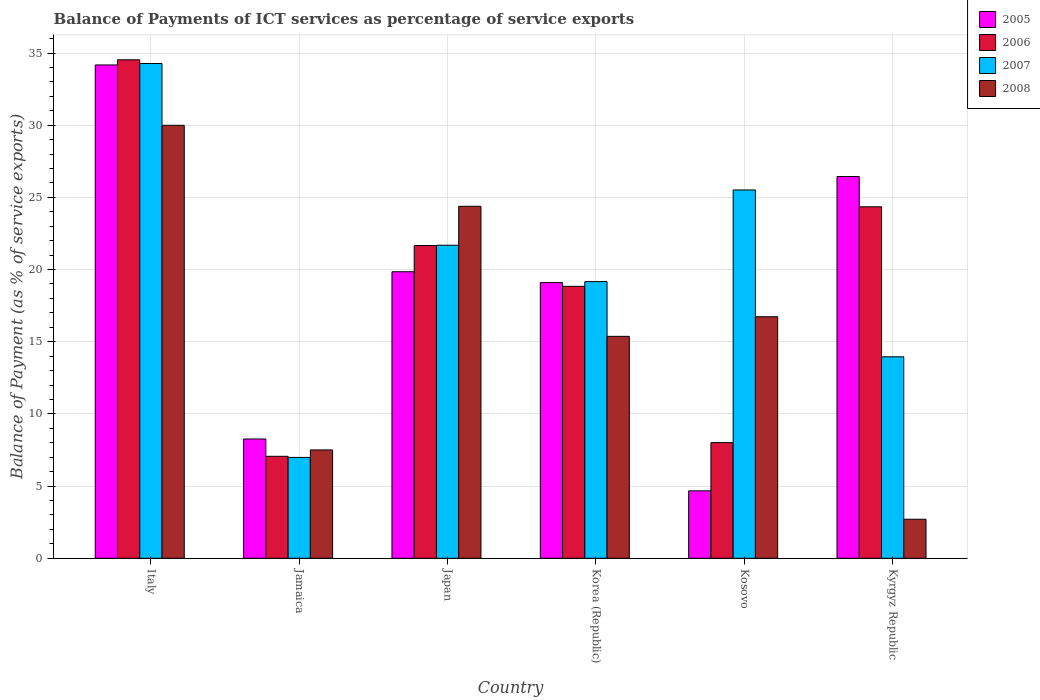How many different coloured bars are there?
Provide a succinct answer. 4. Are the number of bars on each tick of the X-axis equal?
Provide a short and direct response. Yes. How many bars are there on the 5th tick from the right?
Your answer should be very brief. 4. What is the label of the 5th group of bars from the left?
Make the answer very short. Kosovo. In how many cases, is the number of bars for a given country not equal to the number of legend labels?
Keep it short and to the point. 0. What is the balance of payments of ICT services in 2006 in Italy?
Offer a very short reply. 34.53. Across all countries, what is the maximum balance of payments of ICT services in 2008?
Offer a very short reply. 29.99. Across all countries, what is the minimum balance of payments of ICT services in 2007?
Keep it short and to the point. 6.99. In which country was the balance of payments of ICT services in 2005 maximum?
Your answer should be compact. Italy. In which country was the balance of payments of ICT services in 2006 minimum?
Your answer should be very brief. Jamaica. What is the total balance of payments of ICT services in 2008 in the graph?
Ensure brevity in your answer.  96.69. What is the difference between the balance of payments of ICT services in 2007 in Japan and that in Kyrgyz Republic?
Your answer should be very brief. 7.73. What is the difference between the balance of payments of ICT services in 2005 in Korea (Republic) and the balance of payments of ICT services in 2006 in Italy?
Your answer should be compact. -15.43. What is the average balance of payments of ICT services in 2007 per country?
Your answer should be compact. 20.26. What is the difference between the balance of payments of ICT services of/in 2006 and balance of payments of ICT services of/in 2005 in Kyrgyz Republic?
Provide a short and direct response. -2.1. In how many countries, is the balance of payments of ICT services in 2008 greater than 8 %?
Give a very brief answer. 4. What is the ratio of the balance of payments of ICT services in 2008 in Jamaica to that in Korea (Republic)?
Offer a very short reply. 0.49. Is the difference between the balance of payments of ICT services in 2006 in Japan and Kosovo greater than the difference between the balance of payments of ICT services in 2005 in Japan and Kosovo?
Keep it short and to the point. No. What is the difference between the highest and the second highest balance of payments of ICT services in 2008?
Your response must be concise. 7.65. What is the difference between the highest and the lowest balance of payments of ICT services in 2008?
Keep it short and to the point. 27.29. In how many countries, is the balance of payments of ICT services in 2005 greater than the average balance of payments of ICT services in 2005 taken over all countries?
Make the answer very short. 4. Is the sum of the balance of payments of ICT services in 2008 in Korea (Republic) and Kosovo greater than the maximum balance of payments of ICT services in 2005 across all countries?
Offer a very short reply. No. Is it the case that in every country, the sum of the balance of payments of ICT services in 2007 and balance of payments of ICT services in 2005 is greater than the sum of balance of payments of ICT services in 2008 and balance of payments of ICT services in 2006?
Make the answer very short. No. What does the 1st bar from the left in Korea (Republic) represents?
Your answer should be very brief. 2005. What does the 4th bar from the right in Kosovo represents?
Give a very brief answer. 2005. Are all the bars in the graph horizontal?
Your response must be concise. No. How many countries are there in the graph?
Keep it short and to the point. 6. What is the difference between two consecutive major ticks on the Y-axis?
Your answer should be very brief. 5. Are the values on the major ticks of Y-axis written in scientific E-notation?
Your answer should be very brief. No. Does the graph contain any zero values?
Your answer should be compact. No. Does the graph contain grids?
Your answer should be compact. Yes. Where does the legend appear in the graph?
Keep it short and to the point. Top right. How many legend labels are there?
Your response must be concise. 4. What is the title of the graph?
Ensure brevity in your answer.  Balance of Payments of ICT services as percentage of service exports. Does "1993" appear as one of the legend labels in the graph?
Your answer should be very brief. No. What is the label or title of the X-axis?
Give a very brief answer. Country. What is the label or title of the Y-axis?
Keep it short and to the point. Balance of Payment (as % of service exports). What is the Balance of Payment (as % of service exports) of 2005 in Italy?
Your answer should be very brief. 34.17. What is the Balance of Payment (as % of service exports) in 2006 in Italy?
Make the answer very short. 34.53. What is the Balance of Payment (as % of service exports) of 2007 in Italy?
Offer a very short reply. 34.28. What is the Balance of Payment (as % of service exports) in 2008 in Italy?
Your answer should be very brief. 29.99. What is the Balance of Payment (as % of service exports) in 2005 in Jamaica?
Your answer should be very brief. 8.26. What is the Balance of Payment (as % of service exports) in 2006 in Jamaica?
Offer a terse response. 7.06. What is the Balance of Payment (as % of service exports) in 2007 in Jamaica?
Make the answer very short. 6.99. What is the Balance of Payment (as % of service exports) of 2008 in Jamaica?
Your answer should be very brief. 7.5. What is the Balance of Payment (as % of service exports) of 2005 in Japan?
Ensure brevity in your answer.  19.85. What is the Balance of Payment (as % of service exports) of 2006 in Japan?
Your response must be concise. 21.67. What is the Balance of Payment (as % of service exports) in 2007 in Japan?
Your response must be concise. 21.69. What is the Balance of Payment (as % of service exports) of 2008 in Japan?
Give a very brief answer. 24.38. What is the Balance of Payment (as % of service exports) in 2005 in Korea (Republic)?
Give a very brief answer. 19.1. What is the Balance of Payment (as % of service exports) of 2006 in Korea (Republic)?
Your response must be concise. 18.84. What is the Balance of Payment (as % of service exports) of 2007 in Korea (Republic)?
Your answer should be compact. 19.16. What is the Balance of Payment (as % of service exports) of 2008 in Korea (Republic)?
Provide a short and direct response. 15.37. What is the Balance of Payment (as % of service exports) of 2005 in Kosovo?
Provide a short and direct response. 4.67. What is the Balance of Payment (as % of service exports) of 2006 in Kosovo?
Your response must be concise. 8.01. What is the Balance of Payment (as % of service exports) of 2007 in Kosovo?
Ensure brevity in your answer.  25.51. What is the Balance of Payment (as % of service exports) of 2008 in Kosovo?
Keep it short and to the point. 16.73. What is the Balance of Payment (as % of service exports) in 2005 in Kyrgyz Republic?
Your answer should be very brief. 26.45. What is the Balance of Payment (as % of service exports) of 2006 in Kyrgyz Republic?
Your answer should be compact. 24.35. What is the Balance of Payment (as % of service exports) of 2007 in Kyrgyz Republic?
Give a very brief answer. 13.96. What is the Balance of Payment (as % of service exports) of 2008 in Kyrgyz Republic?
Provide a short and direct response. 2.7. Across all countries, what is the maximum Balance of Payment (as % of service exports) of 2005?
Your answer should be compact. 34.17. Across all countries, what is the maximum Balance of Payment (as % of service exports) of 2006?
Keep it short and to the point. 34.53. Across all countries, what is the maximum Balance of Payment (as % of service exports) in 2007?
Make the answer very short. 34.28. Across all countries, what is the maximum Balance of Payment (as % of service exports) in 2008?
Your response must be concise. 29.99. Across all countries, what is the minimum Balance of Payment (as % of service exports) in 2005?
Give a very brief answer. 4.67. Across all countries, what is the minimum Balance of Payment (as % of service exports) of 2006?
Provide a succinct answer. 7.06. Across all countries, what is the minimum Balance of Payment (as % of service exports) of 2007?
Your answer should be compact. 6.99. Across all countries, what is the minimum Balance of Payment (as % of service exports) of 2008?
Ensure brevity in your answer.  2.7. What is the total Balance of Payment (as % of service exports) in 2005 in the graph?
Provide a succinct answer. 112.5. What is the total Balance of Payment (as % of service exports) of 2006 in the graph?
Your answer should be compact. 114.46. What is the total Balance of Payment (as % of service exports) of 2007 in the graph?
Your response must be concise. 121.58. What is the total Balance of Payment (as % of service exports) in 2008 in the graph?
Your answer should be compact. 96.69. What is the difference between the Balance of Payment (as % of service exports) of 2005 in Italy and that in Jamaica?
Make the answer very short. 25.91. What is the difference between the Balance of Payment (as % of service exports) of 2006 in Italy and that in Jamaica?
Give a very brief answer. 27.47. What is the difference between the Balance of Payment (as % of service exports) in 2007 in Italy and that in Jamaica?
Make the answer very short. 27.29. What is the difference between the Balance of Payment (as % of service exports) of 2008 in Italy and that in Jamaica?
Ensure brevity in your answer.  22.49. What is the difference between the Balance of Payment (as % of service exports) of 2005 in Italy and that in Japan?
Make the answer very short. 14.33. What is the difference between the Balance of Payment (as % of service exports) in 2006 in Italy and that in Japan?
Offer a very short reply. 12.87. What is the difference between the Balance of Payment (as % of service exports) of 2007 in Italy and that in Japan?
Your answer should be very brief. 12.59. What is the difference between the Balance of Payment (as % of service exports) in 2008 in Italy and that in Japan?
Keep it short and to the point. 5.61. What is the difference between the Balance of Payment (as % of service exports) of 2005 in Italy and that in Korea (Republic)?
Your answer should be compact. 15.08. What is the difference between the Balance of Payment (as % of service exports) in 2006 in Italy and that in Korea (Republic)?
Provide a short and direct response. 15.69. What is the difference between the Balance of Payment (as % of service exports) of 2007 in Italy and that in Korea (Republic)?
Offer a very short reply. 15.11. What is the difference between the Balance of Payment (as % of service exports) of 2008 in Italy and that in Korea (Republic)?
Your answer should be compact. 14.62. What is the difference between the Balance of Payment (as % of service exports) of 2005 in Italy and that in Kosovo?
Your answer should be compact. 29.5. What is the difference between the Balance of Payment (as % of service exports) in 2006 in Italy and that in Kosovo?
Your answer should be compact. 26.52. What is the difference between the Balance of Payment (as % of service exports) in 2007 in Italy and that in Kosovo?
Offer a very short reply. 8.76. What is the difference between the Balance of Payment (as % of service exports) in 2008 in Italy and that in Kosovo?
Your answer should be very brief. 13.26. What is the difference between the Balance of Payment (as % of service exports) of 2005 in Italy and that in Kyrgyz Republic?
Give a very brief answer. 7.73. What is the difference between the Balance of Payment (as % of service exports) in 2006 in Italy and that in Kyrgyz Republic?
Your answer should be compact. 10.18. What is the difference between the Balance of Payment (as % of service exports) of 2007 in Italy and that in Kyrgyz Republic?
Offer a very short reply. 20.32. What is the difference between the Balance of Payment (as % of service exports) in 2008 in Italy and that in Kyrgyz Republic?
Provide a succinct answer. 27.29. What is the difference between the Balance of Payment (as % of service exports) of 2005 in Jamaica and that in Japan?
Provide a succinct answer. -11.59. What is the difference between the Balance of Payment (as % of service exports) of 2006 in Jamaica and that in Japan?
Give a very brief answer. -14.6. What is the difference between the Balance of Payment (as % of service exports) of 2007 in Jamaica and that in Japan?
Make the answer very short. -14.7. What is the difference between the Balance of Payment (as % of service exports) of 2008 in Jamaica and that in Japan?
Offer a terse response. -16.88. What is the difference between the Balance of Payment (as % of service exports) of 2005 in Jamaica and that in Korea (Republic)?
Your answer should be very brief. -10.83. What is the difference between the Balance of Payment (as % of service exports) of 2006 in Jamaica and that in Korea (Republic)?
Provide a short and direct response. -11.78. What is the difference between the Balance of Payment (as % of service exports) of 2007 in Jamaica and that in Korea (Republic)?
Your answer should be very brief. -12.18. What is the difference between the Balance of Payment (as % of service exports) in 2008 in Jamaica and that in Korea (Republic)?
Provide a succinct answer. -7.87. What is the difference between the Balance of Payment (as % of service exports) in 2005 in Jamaica and that in Kosovo?
Your response must be concise. 3.59. What is the difference between the Balance of Payment (as % of service exports) in 2006 in Jamaica and that in Kosovo?
Offer a terse response. -0.95. What is the difference between the Balance of Payment (as % of service exports) of 2007 in Jamaica and that in Kosovo?
Give a very brief answer. -18.53. What is the difference between the Balance of Payment (as % of service exports) of 2008 in Jamaica and that in Kosovo?
Your response must be concise. -9.23. What is the difference between the Balance of Payment (as % of service exports) in 2005 in Jamaica and that in Kyrgyz Republic?
Provide a succinct answer. -18.18. What is the difference between the Balance of Payment (as % of service exports) in 2006 in Jamaica and that in Kyrgyz Republic?
Your response must be concise. -17.29. What is the difference between the Balance of Payment (as % of service exports) of 2007 in Jamaica and that in Kyrgyz Republic?
Offer a terse response. -6.97. What is the difference between the Balance of Payment (as % of service exports) in 2008 in Jamaica and that in Kyrgyz Republic?
Your answer should be compact. 4.8. What is the difference between the Balance of Payment (as % of service exports) of 2005 in Japan and that in Korea (Republic)?
Your answer should be very brief. 0.75. What is the difference between the Balance of Payment (as % of service exports) in 2006 in Japan and that in Korea (Republic)?
Offer a terse response. 2.83. What is the difference between the Balance of Payment (as % of service exports) of 2007 in Japan and that in Korea (Republic)?
Your response must be concise. 2.52. What is the difference between the Balance of Payment (as % of service exports) of 2008 in Japan and that in Korea (Republic)?
Provide a succinct answer. 9.01. What is the difference between the Balance of Payment (as % of service exports) in 2005 in Japan and that in Kosovo?
Give a very brief answer. 15.18. What is the difference between the Balance of Payment (as % of service exports) of 2006 in Japan and that in Kosovo?
Your response must be concise. 13.66. What is the difference between the Balance of Payment (as % of service exports) in 2007 in Japan and that in Kosovo?
Offer a terse response. -3.83. What is the difference between the Balance of Payment (as % of service exports) of 2008 in Japan and that in Kosovo?
Your answer should be very brief. 7.65. What is the difference between the Balance of Payment (as % of service exports) of 2005 in Japan and that in Kyrgyz Republic?
Keep it short and to the point. -6.6. What is the difference between the Balance of Payment (as % of service exports) in 2006 in Japan and that in Kyrgyz Republic?
Your answer should be very brief. -2.68. What is the difference between the Balance of Payment (as % of service exports) of 2007 in Japan and that in Kyrgyz Republic?
Offer a very short reply. 7.73. What is the difference between the Balance of Payment (as % of service exports) of 2008 in Japan and that in Kyrgyz Republic?
Your response must be concise. 21.68. What is the difference between the Balance of Payment (as % of service exports) in 2005 in Korea (Republic) and that in Kosovo?
Offer a very short reply. 14.43. What is the difference between the Balance of Payment (as % of service exports) of 2006 in Korea (Republic) and that in Kosovo?
Offer a terse response. 10.83. What is the difference between the Balance of Payment (as % of service exports) in 2007 in Korea (Republic) and that in Kosovo?
Offer a very short reply. -6.35. What is the difference between the Balance of Payment (as % of service exports) in 2008 in Korea (Republic) and that in Kosovo?
Offer a very short reply. -1.36. What is the difference between the Balance of Payment (as % of service exports) in 2005 in Korea (Republic) and that in Kyrgyz Republic?
Your answer should be compact. -7.35. What is the difference between the Balance of Payment (as % of service exports) of 2006 in Korea (Republic) and that in Kyrgyz Republic?
Offer a terse response. -5.51. What is the difference between the Balance of Payment (as % of service exports) in 2007 in Korea (Republic) and that in Kyrgyz Republic?
Provide a succinct answer. 5.21. What is the difference between the Balance of Payment (as % of service exports) of 2008 in Korea (Republic) and that in Kyrgyz Republic?
Keep it short and to the point. 12.67. What is the difference between the Balance of Payment (as % of service exports) of 2005 in Kosovo and that in Kyrgyz Republic?
Make the answer very short. -21.77. What is the difference between the Balance of Payment (as % of service exports) of 2006 in Kosovo and that in Kyrgyz Republic?
Your answer should be very brief. -16.34. What is the difference between the Balance of Payment (as % of service exports) of 2007 in Kosovo and that in Kyrgyz Republic?
Your answer should be compact. 11.56. What is the difference between the Balance of Payment (as % of service exports) in 2008 in Kosovo and that in Kyrgyz Republic?
Make the answer very short. 14.03. What is the difference between the Balance of Payment (as % of service exports) of 2005 in Italy and the Balance of Payment (as % of service exports) of 2006 in Jamaica?
Give a very brief answer. 27.11. What is the difference between the Balance of Payment (as % of service exports) in 2005 in Italy and the Balance of Payment (as % of service exports) in 2007 in Jamaica?
Keep it short and to the point. 27.19. What is the difference between the Balance of Payment (as % of service exports) in 2005 in Italy and the Balance of Payment (as % of service exports) in 2008 in Jamaica?
Make the answer very short. 26.67. What is the difference between the Balance of Payment (as % of service exports) of 2006 in Italy and the Balance of Payment (as % of service exports) of 2007 in Jamaica?
Provide a succinct answer. 27.54. What is the difference between the Balance of Payment (as % of service exports) in 2006 in Italy and the Balance of Payment (as % of service exports) in 2008 in Jamaica?
Your response must be concise. 27.03. What is the difference between the Balance of Payment (as % of service exports) of 2007 in Italy and the Balance of Payment (as % of service exports) of 2008 in Jamaica?
Your answer should be very brief. 26.77. What is the difference between the Balance of Payment (as % of service exports) in 2005 in Italy and the Balance of Payment (as % of service exports) in 2006 in Japan?
Your answer should be compact. 12.51. What is the difference between the Balance of Payment (as % of service exports) in 2005 in Italy and the Balance of Payment (as % of service exports) in 2007 in Japan?
Your answer should be compact. 12.49. What is the difference between the Balance of Payment (as % of service exports) of 2005 in Italy and the Balance of Payment (as % of service exports) of 2008 in Japan?
Ensure brevity in your answer.  9.79. What is the difference between the Balance of Payment (as % of service exports) in 2006 in Italy and the Balance of Payment (as % of service exports) in 2007 in Japan?
Make the answer very short. 12.85. What is the difference between the Balance of Payment (as % of service exports) of 2006 in Italy and the Balance of Payment (as % of service exports) of 2008 in Japan?
Offer a very short reply. 10.15. What is the difference between the Balance of Payment (as % of service exports) in 2007 in Italy and the Balance of Payment (as % of service exports) in 2008 in Japan?
Offer a terse response. 9.89. What is the difference between the Balance of Payment (as % of service exports) in 2005 in Italy and the Balance of Payment (as % of service exports) in 2006 in Korea (Republic)?
Offer a terse response. 15.34. What is the difference between the Balance of Payment (as % of service exports) in 2005 in Italy and the Balance of Payment (as % of service exports) in 2007 in Korea (Republic)?
Ensure brevity in your answer.  15.01. What is the difference between the Balance of Payment (as % of service exports) of 2005 in Italy and the Balance of Payment (as % of service exports) of 2008 in Korea (Republic)?
Offer a very short reply. 18.8. What is the difference between the Balance of Payment (as % of service exports) of 2006 in Italy and the Balance of Payment (as % of service exports) of 2007 in Korea (Republic)?
Provide a short and direct response. 15.37. What is the difference between the Balance of Payment (as % of service exports) of 2006 in Italy and the Balance of Payment (as % of service exports) of 2008 in Korea (Republic)?
Keep it short and to the point. 19.16. What is the difference between the Balance of Payment (as % of service exports) in 2007 in Italy and the Balance of Payment (as % of service exports) in 2008 in Korea (Republic)?
Provide a succinct answer. 18.9. What is the difference between the Balance of Payment (as % of service exports) of 2005 in Italy and the Balance of Payment (as % of service exports) of 2006 in Kosovo?
Provide a succinct answer. 26.16. What is the difference between the Balance of Payment (as % of service exports) of 2005 in Italy and the Balance of Payment (as % of service exports) of 2007 in Kosovo?
Offer a very short reply. 8.66. What is the difference between the Balance of Payment (as % of service exports) of 2005 in Italy and the Balance of Payment (as % of service exports) of 2008 in Kosovo?
Give a very brief answer. 17.44. What is the difference between the Balance of Payment (as % of service exports) in 2006 in Italy and the Balance of Payment (as % of service exports) in 2007 in Kosovo?
Give a very brief answer. 9.02. What is the difference between the Balance of Payment (as % of service exports) of 2006 in Italy and the Balance of Payment (as % of service exports) of 2008 in Kosovo?
Your answer should be compact. 17.8. What is the difference between the Balance of Payment (as % of service exports) in 2007 in Italy and the Balance of Payment (as % of service exports) in 2008 in Kosovo?
Provide a succinct answer. 17.54. What is the difference between the Balance of Payment (as % of service exports) in 2005 in Italy and the Balance of Payment (as % of service exports) in 2006 in Kyrgyz Republic?
Provide a succinct answer. 9.82. What is the difference between the Balance of Payment (as % of service exports) of 2005 in Italy and the Balance of Payment (as % of service exports) of 2007 in Kyrgyz Republic?
Give a very brief answer. 20.22. What is the difference between the Balance of Payment (as % of service exports) in 2005 in Italy and the Balance of Payment (as % of service exports) in 2008 in Kyrgyz Republic?
Make the answer very short. 31.47. What is the difference between the Balance of Payment (as % of service exports) of 2006 in Italy and the Balance of Payment (as % of service exports) of 2007 in Kyrgyz Republic?
Give a very brief answer. 20.57. What is the difference between the Balance of Payment (as % of service exports) of 2006 in Italy and the Balance of Payment (as % of service exports) of 2008 in Kyrgyz Republic?
Your response must be concise. 31.83. What is the difference between the Balance of Payment (as % of service exports) of 2007 in Italy and the Balance of Payment (as % of service exports) of 2008 in Kyrgyz Republic?
Offer a terse response. 31.57. What is the difference between the Balance of Payment (as % of service exports) of 2005 in Jamaica and the Balance of Payment (as % of service exports) of 2006 in Japan?
Offer a terse response. -13.4. What is the difference between the Balance of Payment (as % of service exports) in 2005 in Jamaica and the Balance of Payment (as % of service exports) in 2007 in Japan?
Your answer should be compact. -13.42. What is the difference between the Balance of Payment (as % of service exports) in 2005 in Jamaica and the Balance of Payment (as % of service exports) in 2008 in Japan?
Make the answer very short. -16.12. What is the difference between the Balance of Payment (as % of service exports) of 2006 in Jamaica and the Balance of Payment (as % of service exports) of 2007 in Japan?
Offer a terse response. -14.62. What is the difference between the Balance of Payment (as % of service exports) of 2006 in Jamaica and the Balance of Payment (as % of service exports) of 2008 in Japan?
Give a very brief answer. -17.32. What is the difference between the Balance of Payment (as % of service exports) in 2007 in Jamaica and the Balance of Payment (as % of service exports) in 2008 in Japan?
Offer a terse response. -17.39. What is the difference between the Balance of Payment (as % of service exports) of 2005 in Jamaica and the Balance of Payment (as % of service exports) of 2006 in Korea (Republic)?
Offer a terse response. -10.58. What is the difference between the Balance of Payment (as % of service exports) in 2005 in Jamaica and the Balance of Payment (as % of service exports) in 2007 in Korea (Republic)?
Make the answer very short. -10.9. What is the difference between the Balance of Payment (as % of service exports) of 2005 in Jamaica and the Balance of Payment (as % of service exports) of 2008 in Korea (Republic)?
Ensure brevity in your answer.  -7.11. What is the difference between the Balance of Payment (as % of service exports) of 2006 in Jamaica and the Balance of Payment (as % of service exports) of 2007 in Korea (Republic)?
Provide a succinct answer. -12.1. What is the difference between the Balance of Payment (as % of service exports) of 2006 in Jamaica and the Balance of Payment (as % of service exports) of 2008 in Korea (Republic)?
Your response must be concise. -8.31. What is the difference between the Balance of Payment (as % of service exports) in 2007 in Jamaica and the Balance of Payment (as % of service exports) in 2008 in Korea (Republic)?
Make the answer very short. -8.39. What is the difference between the Balance of Payment (as % of service exports) in 2005 in Jamaica and the Balance of Payment (as % of service exports) in 2006 in Kosovo?
Ensure brevity in your answer.  0.25. What is the difference between the Balance of Payment (as % of service exports) of 2005 in Jamaica and the Balance of Payment (as % of service exports) of 2007 in Kosovo?
Keep it short and to the point. -17.25. What is the difference between the Balance of Payment (as % of service exports) in 2005 in Jamaica and the Balance of Payment (as % of service exports) in 2008 in Kosovo?
Your answer should be compact. -8.47. What is the difference between the Balance of Payment (as % of service exports) in 2006 in Jamaica and the Balance of Payment (as % of service exports) in 2007 in Kosovo?
Offer a very short reply. -18.45. What is the difference between the Balance of Payment (as % of service exports) of 2006 in Jamaica and the Balance of Payment (as % of service exports) of 2008 in Kosovo?
Offer a very short reply. -9.67. What is the difference between the Balance of Payment (as % of service exports) of 2007 in Jamaica and the Balance of Payment (as % of service exports) of 2008 in Kosovo?
Make the answer very short. -9.74. What is the difference between the Balance of Payment (as % of service exports) in 2005 in Jamaica and the Balance of Payment (as % of service exports) in 2006 in Kyrgyz Republic?
Your answer should be very brief. -16.09. What is the difference between the Balance of Payment (as % of service exports) in 2005 in Jamaica and the Balance of Payment (as % of service exports) in 2007 in Kyrgyz Republic?
Provide a succinct answer. -5.69. What is the difference between the Balance of Payment (as % of service exports) in 2005 in Jamaica and the Balance of Payment (as % of service exports) in 2008 in Kyrgyz Republic?
Ensure brevity in your answer.  5.56. What is the difference between the Balance of Payment (as % of service exports) in 2006 in Jamaica and the Balance of Payment (as % of service exports) in 2007 in Kyrgyz Republic?
Your answer should be very brief. -6.89. What is the difference between the Balance of Payment (as % of service exports) in 2006 in Jamaica and the Balance of Payment (as % of service exports) in 2008 in Kyrgyz Republic?
Your answer should be very brief. 4.36. What is the difference between the Balance of Payment (as % of service exports) of 2007 in Jamaica and the Balance of Payment (as % of service exports) of 2008 in Kyrgyz Republic?
Your answer should be very brief. 4.28. What is the difference between the Balance of Payment (as % of service exports) in 2005 in Japan and the Balance of Payment (as % of service exports) in 2006 in Korea (Republic)?
Your answer should be compact. 1.01. What is the difference between the Balance of Payment (as % of service exports) in 2005 in Japan and the Balance of Payment (as % of service exports) in 2007 in Korea (Republic)?
Your answer should be very brief. 0.68. What is the difference between the Balance of Payment (as % of service exports) in 2005 in Japan and the Balance of Payment (as % of service exports) in 2008 in Korea (Republic)?
Provide a succinct answer. 4.48. What is the difference between the Balance of Payment (as % of service exports) in 2006 in Japan and the Balance of Payment (as % of service exports) in 2007 in Korea (Republic)?
Provide a succinct answer. 2.5. What is the difference between the Balance of Payment (as % of service exports) in 2006 in Japan and the Balance of Payment (as % of service exports) in 2008 in Korea (Republic)?
Ensure brevity in your answer.  6.29. What is the difference between the Balance of Payment (as % of service exports) of 2007 in Japan and the Balance of Payment (as % of service exports) of 2008 in Korea (Republic)?
Make the answer very short. 6.31. What is the difference between the Balance of Payment (as % of service exports) in 2005 in Japan and the Balance of Payment (as % of service exports) in 2006 in Kosovo?
Provide a succinct answer. 11.84. What is the difference between the Balance of Payment (as % of service exports) of 2005 in Japan and the Balance of Payment (as % of service exports) of 2007 in Kosovo?
Provide a succinct answer. -5.67. What is the difference between the Balance of Payment (as % of service exports) of 2005 in Japan and the Balance of Payment (as % of service exports) of 2008 in Kosovo?
Offer a very short reply. 3.12. What is the difference between the Balance of Payment (as % of service exports) in 2006 in Japan and the Balance of Payment (as % of service exports) in 2007 in Kosovo?
Provide a short and direct response. -3.85. What is the difference between the Balance of Payment (as % of service exports) in 2006 in Japan and the Balance of Payment (as % of service exports) in 2008 in Kosovo?
Offer a very short reply. 4.93. What is the difference between the Balance of Payment (as % of service exports) of 2007 in Japan and the Balance of Payment (as % of service exports) of 2008 in Kosovo?
Keep it short and to the point. 4.95. What is the difference between the Balance of Payment (as % of service exports) of 2005 in Japan and the Balance of Payment (as % of service exports) of 2006 in Kyrgyz Republic?
Your response must be concise. -4.5. What is the difference between the Balance of Payment (as % of service exports) in 2005 in Japan and the Balance of Payment (as % of service exports) in 2007 in Kyrgyz Republic?
Your answer should be compact. 5.89. What is the difference between the Balance of Payment (as % of service exports) in 2005 in Japan and the Balance of Payment (as % of service exports) in 2008 in Kyrgyz Republic?
Offer a very short reply. 17.15. What is the difference between the Balance of Payment (as % of service exports) in 2006 in Japan and the Balance of Payment (as % of service exports) in 2007 in Kyrgyz Republic?
Give a very brief answer. 7.71. What is the difference between the Balance of Payment (as % of service exports) of 2006 in Japan and the Balance of Payment (as % of service exports) of 2008 in Kyrgyz Republic?
Your response must be concise. 18.96. What is the difference between the Balance of Payment (as % of service exports) in 2007 in Japan and the Balance of Payment (as % of service exports) in 2008 in Kyrgyz Republic?
Give a very brief answer. 18.98. What is the difference between the Balance of Payment (as % of service exports) of 2005 in Korea (Republic) and the Balance of Payment (as % of service exports) of 2006 in Kosovo?
Ensure brevity in your answer.  11.09. What is the difference between the Balance of Payment (as % of service exports) in 2005 in Korea (Republic) and the Balance of Payment (as % of service exports) in 2007 in Kosovo?
Provide a succinct answer. -6.42. What is the difference between the Balance of Payment (as % of service exports) in 2005 in Korea (Republic) and the Balance of Payment (as % of service exports) in 2008 in Kosovo?
Give a very brief answer. 2.37. What is the difference between the Balance of Payment (as % of service exports) in 2006 in Korea (Republic) and the Balance of Payment (as % of service exports) in 2007 in Kosovo?
Provide a short and direct response. -6.68. What is the difference between the Balance of Payment (as % of service exports) of 2006 in Korea (Republic) and the Balance of Payment (as % of service exports) of 2008 in Kosovo?
Provide a short and direct response. 2.11. What is the difference between the Balance of Payment (as % of service exports) of 2007 in Korea (Republic) and the Balance of Payment (as % of service exports) of 2008 in Kosovo?
Keep it short and to the point. 2.43. What is the difference between the Balance of Payment (as % of service exports) in 2005 in Korea (Republic) and the Balance of Payment (as % of service exports) in 2006 in Kyrgyz Republic?
Ensure brevity in your answer.  -5.25. What is the difference between the Balance of Payment (as % of service exports) of 2005 in Korea (Republic) and the Balance of Payment (as % of service exports) of 2007 in Kyrgyz Republic?
Your response must be concise. 5.14. What is the difference between the Balance of Payment (as % of service exports) of 2005 in Korea (Republic) and the Balance of Payment (as % of service exports) of 2008 in Kyrgyz Republic?
Ensure brevity in your answer.  16.39. What is the difference between the Balance of Payment (as % of service exports) of 2006 in Korea (Republic) and the Balance of Payment (as % of service exports) of 2007 in Kyrgyz Republic?
Your answer should be compact. 4.88. What is the difference between the Balance of Payment (as % of service exports) of 2006 in Korea (Republic) and the Balance of Payment (as % of service exports) of 2008 in Kyrgyz Republic?
Your answer should be compact. 16.13. What is the difference between the Balance of Payment (as % of service exports) of 2007 in Korea (Republic) and the Balance of Payment (as % of service exports) of 2008 in Kyrgyz Republic?
Offer a terse response. 16.46. What is the difference between the Balance of Payment (as % of service exports) in 2005 in Kosovo and the Balance of Payment (as % of service exports) in 2006 in Kyrgyz Republic?
Ensure brevity in your answer.  -19.68. What is the difference between the Balance of Payment (as % of service exports) in 2005 in Kosovo and the Balance of Payment (as % of service exports) in 2007 in Kyrgyz Republic?
Give a very brief answer. -9.29. What is the difference between the Balance of Payment (as % of service exports) of 2005 in Kosovo and the Balance of Payment (as % of service exports) of 2008 in Kyrgyz Republic?
Ensure brevity in your answer.  1.97. What is the difference between the Balance of Payment (as % of service exports) in 2006 in Kosovo and the Balance of Payment (as % of service exports) in 2007 in Kyrgyz Republic?
Your answer should be very brief. -5.95. What is the difference between the Balance of Payment (as % of service exports) in 2006 in Kosovo and the Balance of Payment (as % of service exports) in 2008 in Kyrgyz Republic?
Offer a terse response. 5.31. What is the difference between the Balance of Payment (as % of service exports) in 2007 in Kosovo and the Balance of Payment (as % of service exports) in 2008 in Kyrgyz Republic?
Your answer should be very brief. 22.81. What is the average Balance of Payment (as % of service exports) in 2005 per country?
Make the answer very short. 18.75. What is the average Balance of Payment (as % of service exports) in 2006 per country?
Offer a very short reply. 19.08. What is the average Balance of Payment (as % of service exports) in 2007 per country?
Give a very brief answer. 20.26. What is the average Balance of Payment (as % of service exports) in 2008 per country?
Your response must be concise. 16.11. What is the difference between the Balance of Payment (as % of service exports) in 2005 and Balance of Payment (as % of service exports) in 2006 in Italy?
Keep it short and to the point. -0.36. What is the difference between the Balance of Payment (as % of service exports) in 2005 and Balance of Payment (as % of service exports) in 2007 in Italy?
Your answer should be very brief. -0.1. What is the difference between the Balance of Payment (as % of service exports) of 2005 and Balance of Payment (as % of service exports) of 2008 in Italy?
Make the answer very short. 4.18. What is the difference between the Balance of Payment (as % of service exports) of 2006 and Balance of Payment (as % of service exports) of 2007 in Italy?
Offer a very short reply. 0.26. What is the difference between the Balance of Payment (as % of service exports) in 2006 and Balance of Payment (as % of service exports) in 2008 in Italy?
Your response must be concise. 4.54. What is the difference between the Balance of Payment (as % of service exports) in 2007 and Balance of Payment (as % of service exports) in 2008 in Italy?
Provide a succinct answer. 4.28. What is the difference between the Balance of Payment (as % of service exports) in 2005 and Balance of Payment (as % of service exports) in 2006 in Jamaica?
Keep it short and to the point. 1.2. What is the difference between the Balance of Payment (as % of service exports) in 2005 and Balance of Payment (as % of service exports) in 2007 in Jamaica?
Provide a succinct answer. 1.28. What is the difference between the Balance of Payment (as % of service exports) of 2005 and Balance of Payment (as % of service exports) of 2008 in Jamaica?
Make the answer very short. 0.76. What is the difference between the Balance of Payment (as % of service exports) of 2006 and Balance of Payment (as % of service exports) of 2007 in Jamaica?
Ensure brevity in your answer.  0.08. What is the difference between the Balance of Payment (as % of service exports) in 2006 and Balance of Payment (as % of service exports) in 2008 in Jamaica?
Ensure brevity in your answer.  -0.44. What is the difference between the Balance of Payment (as % of service exports) of 2007 and Balance of Payment (as % of service exports) of 2008 in Jamaica?
Offer a very short reply. -0.52. What is the difference between the Balance of Payment (as % of service exports) of 2005 and Balance of Payment (as % of service exports) of 2006 in Japan?
Keep it short and to the point. -1.82. What is the difference between the Balance of Payment (as % of service exports) in 2005 and Balance of Payment (as % of service exports) in 2007 in Japan?
Provide a short and direct response. -1.84. What is the difference between the Balance of Payment (as % of service exports) in 2005 and Balance of Payment (as % of service exports) in 2008 in Japan?
Provide a short and direct response. -4.53. What is the difference between the Balance of Payment (as % of service exports) of 2006 and Balance of Payment (as % of service exports) of 2007 in Japan?
Your response must be concise. -0.02. What is the difference between the Balance of Payment (as % of service exports) of 2006 and Balance of Payment (as % of service exports) of 2008 in Japan?
Make the answer very short. -2.72. What is the difference between the Balance of Payment (as % of service exports) in 2007 and Balance of Payment (as % of service exports) in 2008 in Japan?
Offer a terse response. -2.7. What is the difference between the Balance of Payment (as % of service exports) of 2005 and Balance of Payment (as % of service exports) of 2006 in Korea (Republic)?
Give a very brief answer. 0.26. What is the difference between the Balance of Payment (as % of service exports) in 2005 and Balance of Payment (as % of service exports) in 2007 in Korea (Republic)?
Your answer should be very brief. -0.07. What is the difference between the Balance of Payment (as % of service exports) of 2005 and Balance of Payment (as % of service exports) of 2008 in Korea (Republic)?
Offer a terse response. 3.72. What is the difference between the Balance of Payment (as % of service exports) in 2006 and Balance of Payment (as % of service exports) in 2007 in Korea (Republic)?
Make the answer very short. -0.33. What is the difference between the Balance of Payment (as % of service exports) in 2006 and Balance of Payment (as % of service exports) in 2008 in Korea (Republic)?
Keep it short and to the point. 3.46. What is the difference between the Balance of Payment (as % of service exports) of 2007 and Balance of Payment (as % of service exports) of 2008 in Korea (Republic)?
Offer a terse response. 3.79. What is the difference between the Balance of Payment (as % of service exports) in 2005 and Balance of Payment (as % of service exports) in 2006 in Kosovo?
Offer a terse response. -3.34. What is the difference between the Balance of Payment (as % of service exports) of 2005 and Balance of Payment (as % of service exports) of 2007 in Kosovo?
Your response must be concise. -20.84. What is the difference between the Balance of Payment (as % of service exports) of 2005 and Balance of Payment (as % of service exports) of 2008 in Kosovo?
Keep it short and to the point. -12.06. What is the difference between the Balance of Payment (as % of service exports) in 2006 and Balance of Payment (as % of service exports) in 2007 in Kosovo?
Ensure brevity in your answer.  -17.5. What is the difference between the Balance of Payment (as % of service exports) of 2006 and Balance of Payment (as % of service exports) of 2008 in Kosovo?
Offer a very short reply. -8.72. What is the difference between the Balance of Payment (as % of service exports) in 2007 and Balance of Payment (as % of service exports) in 2008 in Kosovo?
Offer a terse response. 8.78. What is the difference between the Balance of Payment (as % of service exports) of 2005 and Balance of Payment (as % of service exports) of 2006 in Kyrgyz Republic?
Provide a succinct answer. 2.1. What is the difference between the Balance of Payment (as % of service exports) in 2005 and Balance of Payment (as % of service exports) in 2007 in Kyrgyz Republic?
Your answer should be very brief. 12.49. What is the difference between the Balance of Payment (as % of service exports) of 2005 and Balance of Payment (as % of service exports) of 2008 in Kyrgyz Republic?
Offer a very short reply. 23.74. What is the difference between the Balance of Payment (as % of service exports) in 2006 and Balance of Payment (as % of service exports) in 2007 in Kyrgyz Republic?
Ensure brevity in your answer.  10.39. What is the difference between the Balance of Payment (as % of service exports) of 2006 and Balance of Payment (as % of service exports) of 2008 in Kyrgyz Republic?
Keep it short and to the point. 21.65. What is the difference between the Balance of Payment (as % of service exports) in 2007 and Balance of Payment (as % of service exports) in 2008 in Kyrgyz Republic?
Keep it short and to the point. 11.25. What is the ratio of the Balance of Payment (as % of service exports) of 2005 in Italy to that in Jamaica?
Provide a short and direct response. 4.14. What is the ratio of the Balance of Payment (as % of service exports) in 2006 in Italy to that in Jamaica?
Provide a short and direct response. 4.89. What is the ratio of the Balance of Payment (as % of service exports) of 2007 in Italy to that in Jamaica?
Ensure brevity in your answer.  4.91. What is the ratio of the Balance of Payment (as % of service exports) in 2008 in Italy to that in Jamaica?
Offer a very short reply. 4. What is the ratio of the Balance of Payment (as % of service exports) in 2005 in Italy to that in Japan?
Offer a very short reply. 1.72. What is the ratio of the Balance of Payment (as % of service exports) of 2006 in Italy to that in Japan?
Your answer should be compact. 1.59. What is the ratio of the Balance of Payment (as % of service exports) in 2007 in Italy to that in Japan?
Your answer should be compact. 1.58. What is the ratio of the Balance of Payment (as % of service exports) in 2008 in Italy to that in Japan?
Provide a short and direct response. 1.23. What is the ratio of the Balance of Payment (as % of service exports) in 2005 in Italy to that in Korea (Republic)?
Your response must be concise. 1.79. What is the ratio of the Balance of Payment (as % of service exports) of 2006 in Italy to that in Korea (Republic)?
Offer a terse response. 1.83. What is the ratio of the Balance of Payment (as % of service exports) of 2007 in Italy to that in Korea (Republic)?
Provide a succinct answer. 1.79. What is the ratio of the Balance of Payment (as % of service exports) of 2008 in Italy to that in Korea (Republic)?
Your answer should be very brief. 1.95. What is the ratio of the Balance of Payment (as % of service exports) in 2005 in Italy to that in Kosovo?
Give a very brief answer. 7.32. What is the ratio of the Balance of Payment (as % of service exports) in 2006 in Italy to that in Kosovo?
Keep it short and to the point. 4.31. What is the ratio of the Balance of Payment (as % of service exports) in 2007 in Italy to that in Kosovo?
Offer a terse response. 1.34. What is the ratio of the Balance of Payment (as % of service exports) of 2008 in Italy to that in Kosovo?
Ensure brevity in your answer.  1.79. What is the ratio of the Balance of Payment (as % of service exports) of 2005 in Italy to that in Kyrgyz Republic?
Ensure brevity in your answer.  1.29. What is the ratio of the Balance of Payment (as % of service exports) of 2006 in Italy to that in Kyrgyz Republic?
Keep it short and to the point. 1.42. What is the ratio of the Balance of Payment (as % of service exports) in 2007 in Italy to that in Kyrgyz Republic?
Your response must be concise. 2.46. What is the ratio of the Balance of Payment (as % of service exports) in 2008 in Italy to that in Kyrgyz Republic?
Offer a very short reply. 11.09. What is the ratio of the Balance of Payment (as % of service exports) of 2005 in Jamaica to that in Japan?
Your response must be concise. 0.42. What is the ratio of the Balance of Payment (as % of service exports) of 2006 in Jamaica to that in Japan?
Offer a terse response. 0.33. What is the ratio of the Balance of Payment (as % of service exports) of 2007 in Jamaica to that in Japan?
Offer a very short reply. 0.32. What is the ratio of the Balance of Payment (as % of service exports) in 2008 in Jamaica to that in Japan?
Your response must be concise. 0.31. What is the ratio of the Balance of Payment (as % of service exports) in 2005 in Jamaica to that in Korea (Republic)?
Your answer should be very brief. 0.43. What is the ratio of the Balance of Payment (as % of service exports) in 2006 in Jamaica to that in Korea (Republic)?
Provide a succinct answer. 0.37. What is the ratio of the Balance of Payment (as % of service exports) of 2007 in Jamaica to that in Korea (Republic)?
Offer a very short reply. 0.36. What is the ratio of the Balance of Payment (as % of service exports) of 2008 in Jamaica to that in Korea (Republic)?
Your answer should be very brief. 0.49. What is the ratio of the Balance of Payment (as % of service exports) of 2005 in Jamaica to that in Kosovo?
Offer a terse response. 1.77. What is the ratio of the Balance of Payment (as % of service exports) of 2006 in Jamaica to that in Kosovo?
Keep it short and to the point. 0.88. What is the ratio of the Balance of Payment (as % of service exports) of 2007 in Jamaica to that in Kosovo?
Your answer should be compact. 0.27. What is the ratio of the Balance of Payment (as % of service exports) in 2008 in Jamaica to that in Kosovo?
Your response must be concise. 0.45. What is the ratio of the Balance of Payment (as % of service exports) in 2005 in Jamaica to that in Kyrgyz Republic?
Provide a short and direct response. 0.31. What is the ratio of the Balance of Payment (as % of service exports) in 2006 in Jamaica to that in Kyrgyz Republic?
Offer a terse response. 0.29. What is the ratio of the Balance of Payment (as % of service exports) in 2007 in Jamaica to that in Kyrgyz Republic?
Your answer should be very brief. 0.5. What is the ratio of the Balance of Payment (as % of service exports) of 2008 in Jamaica to that in Kyrgyz Republic?
Keep it short and to the point. 2.78. What is the ratio of the Balance of Payment (as % of service exports) in 2005 in Japan to that in Korea (Republic)?
Keep it short and to the point. 1.04. What is the ratio of the Balance of Payment (as % of service exports) of 2006 in Japan to that in Korea (Republic)?
Your response must be concise. 1.15. What is the ratio of the Balance of Payment (as % of service exports) of 2007 in Japan to that in Korea (Republic)?
Offer a terse response. 1.13. What is the ratio of the Balance of Payment (as % of service exports) of 2008 in Japan to that in Korea (Republic)?
Your answer should be very brief. 1.59. What is the ratio of the Balance of Payment (as % of service exports) in 2005 in Japan to that in Kosovo?
Make the answer very short. 4.25. What is the ratio of the Balance of Payment (as % of service exports) of 2006 in Japan to that in Kosovo?
Provide a short and direct response. 2.7. What is the ratio of the Balance of Payment (as % of service exports) of 2007 in Japan to that in Kosovo?
Offer a very short reply. 0.85. What is the ratio of the Balance of Payment (as % of service exports) in 2008 in Japan to that in Kosovo?
Your answer should be very brief. 1.46. What is the ratio of the Balance of Payment (as % of service exports) in 2005 in Japan to that in Kyrgyz Republic?
Offer a terse response. 0.75. What is the ratio of the Balance of Payment (as % of service exports) of 2006 in Japan to that in Kyrgyz Republic?
Provide a short and direct response. 0.89. What is the ratio of the Balance of Payment (as % of service exports) of 2007 in Japan to that in Kyrgyz Republic?
Your response must be concise. 1.55. What is the ratio of the Balance of Payment (as % of service exports) of 2008 in Japan to that in Kyrgyz Republic?
Make the answer very short. 9.02. What is the ratio of the Balance of Payment (as % of service exports) in 2005 in Korea (Republic) to that in Kosovo?
Your answer should be very brief. 4.09. What is the ratio of the Balance of Payment (as % of service exports) in 2006 in Korea (Republic) to that in Kosovo?
Offer a very short reply. 2.35. What is the ratio of the Balance of Payment (as % of service exports) of 2007 in Korea (Republic) to that in Kosovo?
Ensure brevity in your answer.  0.75. What is the ratio of the Balance of Payment (as % of service exports) in 2008 in Korea (Republic) to that in Kosovo?
Your answer should be very brief. 0.92. What is the ratio of the Balance of Payment (as % of service exports) of 2005 in Korea (Republic) to that in Kyrgyz Republic?
Ensure brevity in your answer.  0.72. What is the ratio of the Balance of Payment (as % of service exports) of 2006 in Korea (Republic) to that in Kyrgyz Republic?
Your response must be concise. 0.77. What is the ratio of the Balance of Payment (as % of service exports) of 2007 in Korea (Republic) to that in Kyrgyz Republic?
Give a very brief answer. 1.37. What is the ratio of the Balance of Payment (as % of service exports) in 2008 in Korea (Republic) to that in Kyrgyz Republic?
Make the answer very short. 5.69. What is the ratio of the Balance of Payment (as % of service exports) in 2005 in Kosovo to that in Kyrgyz Republic?
Offer a terse response. 0.18. What is the ratio of the Balance of Payment (as % of service exports) of 2006 in Kosovo to that in Kyrgyz Republic?
Offer a terse response. 0.33. What is the ratio of the Balance of Payment (as % of service exports) of 2007 in Kosovo to that in Kyrgyz Republic?
Offer a terse response. 1.83. What is the ratio of the Balance of Payment (as % of service exports) of 2008 in Kosovo to that in Kyrgyz Republic?
Your response must be concise. 6.19. What is the difference between the highest and the second highest Balance of Payment (as % of service exports) in 2005?
Offer a very short reply. 7.73. What is the difference between the highest and the second highest Balance of Payment (as % of service exports) in 2006?
Make the answer very short. 10.18. What is the difference between the highest and the second highest Balance of Payment (as % of service exports) in 2007?
Provide a short and direct response. 8.76. What is the difference between the highest and the second highest Balance of Payment (as % of service exports) in 2008?
Make the answer very short. 5.61. What is the difference between the highest and the lowest Balance of Payment (as % of service exports) of 2005?
Your response must be concise. 29.5. What is the difference between the highest and the lowest Balance of Payment (as % of service exports) of 2006?
Provide a succinct answer. 27.47. What is the difference between the highest and the lowest Balance of Payment (as % of service exports) in 2007?
Give a very brief answer. 27.29. What is the difference between the highest and the lowest Balance of Payment (as % of service exports) of 2008?
Your answer should be very brief. 27.29. 